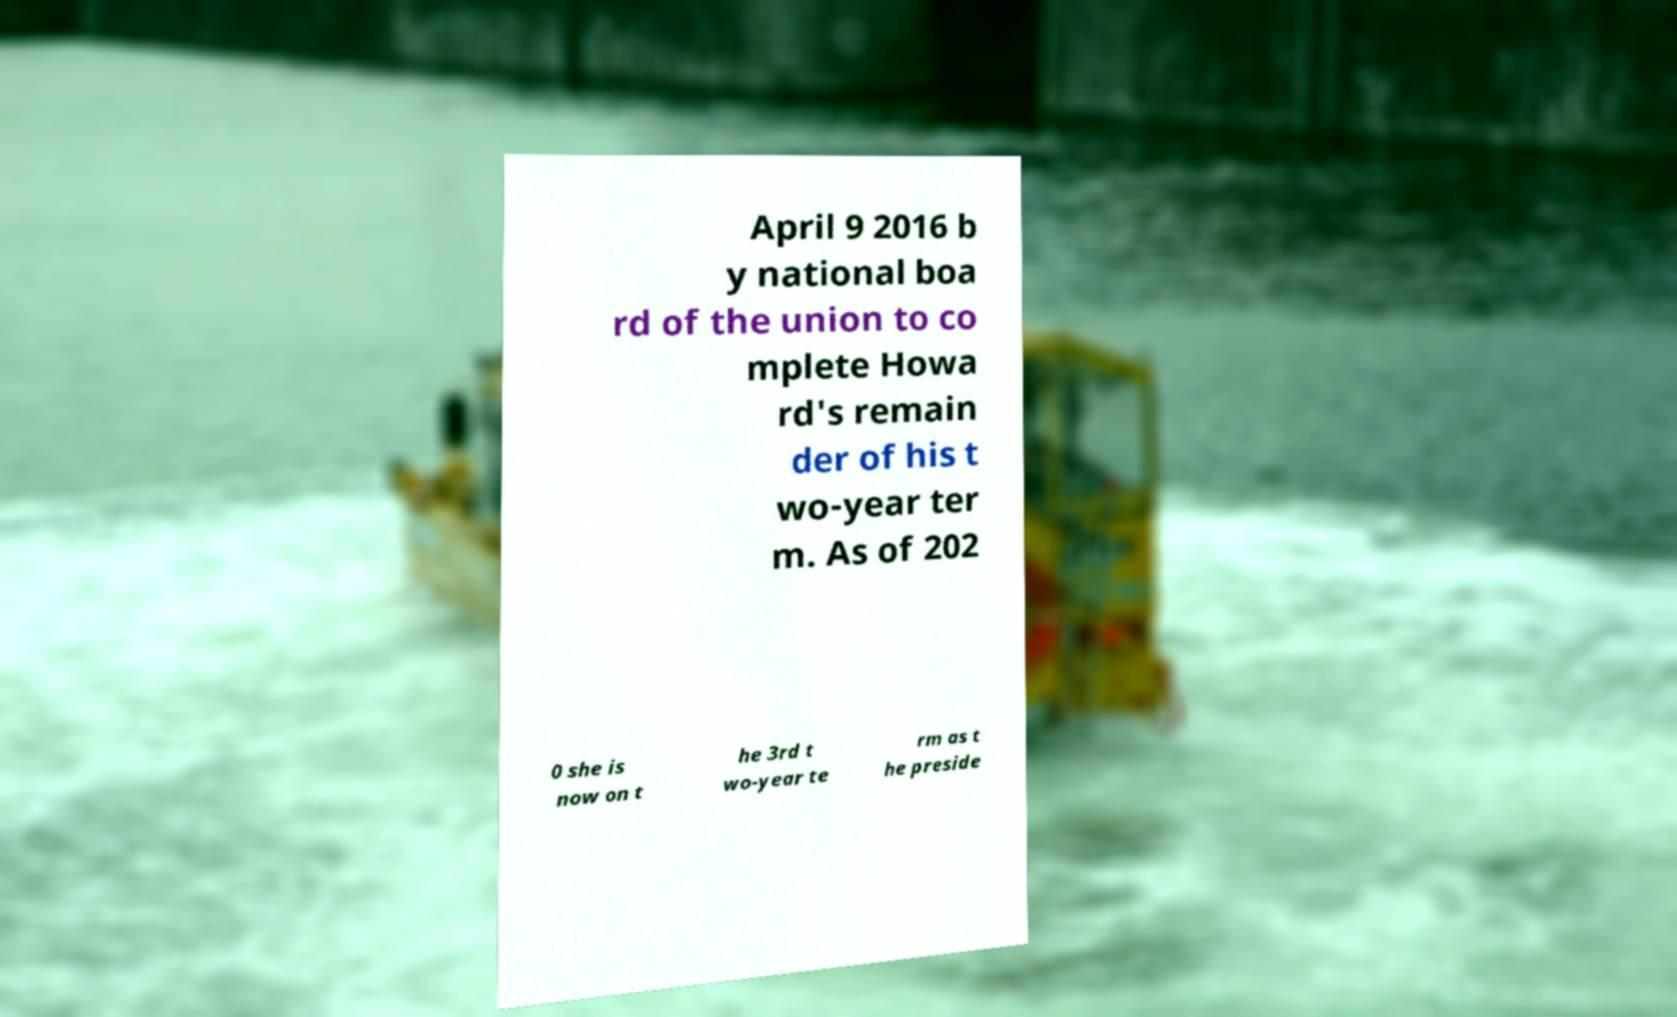There's text embedded in this image that I need extracted. Can you transcribe it verbatim? April 9 2016 b y national boa rd of the union to co mplete Howa rd's remain der of his t wo-year ter m. As of 202 0 she is now on t he 3rd t wo-year te rm as t he preside 